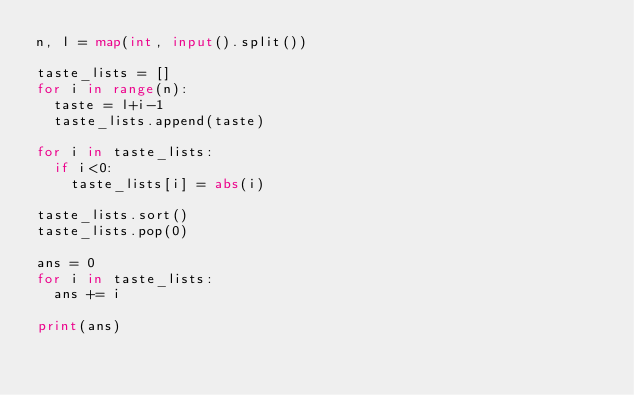Convert code to text. <code><loc_0><loc_0><loc_500><loc_500><_Python_>n, l = map(int, input().split())

taste_lists = []
for i in range(n):
  taste = l+i-1
  taste_lists.append(taste)

for i in taste_lists:
  if i<0:
    taste_lists[i] = abs(i)

taste_lists.sort()
taste_lists.pop(0)

ans = 0
for i in taste_lists:
  ans += i
  
print(ans)</code> 